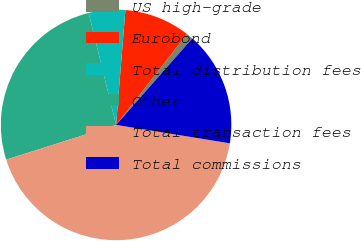<chart> <loc_0><loc_0><loc_500><loc_500><pie_chart><fcel>US high-grade<fcel>Eurobond<fcel>Total distribution fees<fcel>Other<fcel>Total transaction fees<fcel>Total commissions<nl><fcel>0.94%<fcel>9.27%<fcel>5.11%<fcel>26.05%<fcel>42.58%<fcel>16.06%<nl></chart> 